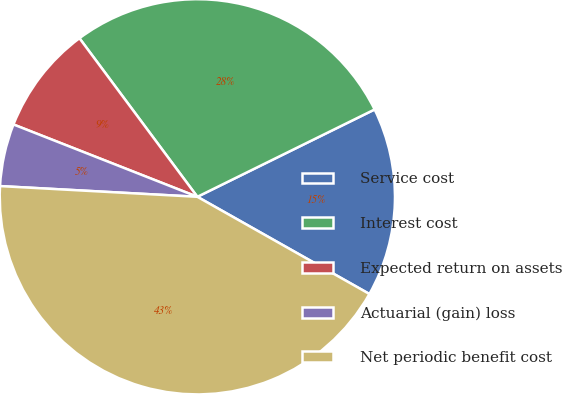Convert chart to OTSL. <chart><loc_0><loc_0><loc_500><loc_500><pie_chart><fcel>Service cost<fcel>Interest cost<fcel>Expected return on assets<fcel>Actuarial (gain) loss<fcel>Net periodic benefit cost<nl><fcel>15.47%<fcel>27.89%<fcel>8.86%<fcel>5.1%<fcel>42.68%<nl></chart> 